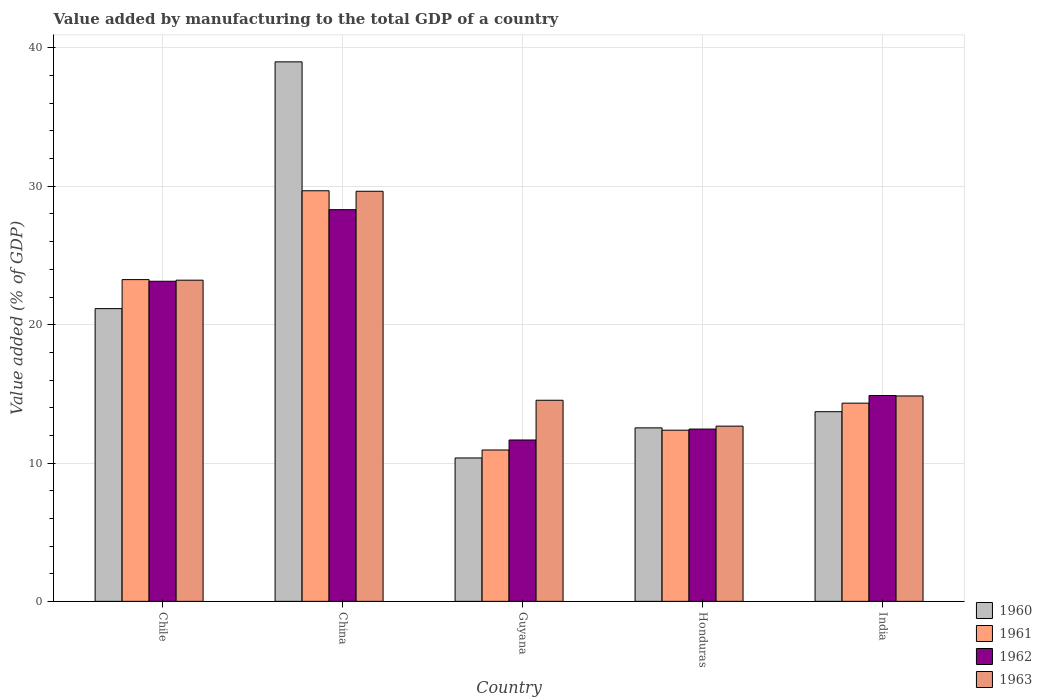How many bars are there on the 5th tick from the left?
Give a very brief answer. 4. How many bars are there on the 4th tick from the right?
Your answer should be compact. 4. What is the label of the 2nd group of bars from the left?
Provide a succinct answer. China. What is the value added by manufacturing to the total GDP in 1961 in China?
Keep it short and to the point. 29.68. Across all countries, what is the maximum value added by manufacturing to the total GDP in 1960?
Provide a succinct answer. 39. Across all countries, what is the minimum value added by manufacturing to the total GDP in 1960?
Keep it short and to the point. 10.37. In which country was the value added by manufacturing to the total GDP in 1963 maximum?
Make the answer very short. China. In which country was the value added by manufacturing to the total GDP in 1962 minimum?
Provide a short and direct response. Guyana. What is the total value added by manufacturing to the total GDP in 1963 in the graph?
Provide a short and direct response. 94.91. What is the difference between the value added by manufacturing to the total GDP in 1961 in China and that in Honduras?
Give a very brief answer. 17.31. What is the difference between the value added by manufacturing to the total GDP in 1961 in India and the value added by manufacturing to the total GDP in 1960 in Guyana?
Provide a succinct answer. 3.96. What is the average value added by manufacturing to the total GDP in 1960 per country?
Ensure brevity in your answer.  19.35. What is the difference between the value added by manufacturing to the total GDP of/in 1963 and value added by manufacturing to the total GDP of/in 1960 in Chile?
Your answer should be very brief. 2.06. What is the ratio of the value added by manufacturing to the total GDP in 1960 in China to that in Honduras?
Provide a succinct answer. 3.11. What is the difference between the highest and the second highest value added by manufacturing to the total GDP in 1962?
Your response must be concise. 13.43. What is the difference between the highest and the lowest value added by manufacturing to the total GDP in 1962?
Your answer should be very brief. 16.65. In how many countries, is the value added by manufacturing to the total GDP in 1963 greater than the average value added by manufacturing to the total GDP in 1963 taken over all countries?
Provide a short and direct response. 2. Is the sum of the value added by manufacturing to the total GDP in 1963 in Chile and Honduras greater than the maximum value added by manufacturing to the total GDP in 1961 across all countries?
Keep it short and to the point. Yes. Is it the case that in every country, the sum of the value added by manufacturing to the total GDP in 1962 and value added by manufacturing to the total GDP in 1963 is greater than the sum of value added by manufacturing to the total GDP in 1960 and value added by manufacturing to the total GDP in 1961?
Make the answer very short. No. What does the 3rd bar from the right in Chile represents?
Offer a very short reply. 1961. Is it the case that in every country, the sum of the value added by manufacturing to the total GDP in 1963 and value added by manufacturing to the total GDP in 1962 is greater than the value added by manufacturing to the total GDP in 1960?
Give a very brief answer. Yes. How many bars are there?
Your response must be concise. 20. How many countries are there in the graph?
Give a very brief answer. 5. What is the difference between two consecutive major ticks on the Y-axis?
Make the answer very short. 10. Are the values on the major ticks of Y-axis written in scientific E-notation?
Make the answer very short. No. How are the legend labels stacked?
Your answer should be compact. Vertical. What is the title of the graph?
Make the answer very short. Value added by manufacturing to the total GDP of a country. Does "1990" appear as one of the legend labels in the graph?
Offer a very short reply. No. What is the label or title of the X-axis?
Your answer should be very brief. Country. What is the label or title of the Y-axis?
Your answer should be very brief. Value added (% of GDP). What is the Value added (% of GDP) of 1960 in Chile?
Your answer should be compact. 21.16. What is the Value added (% of GDP) in 1961 in Chile?
Your answer should be very brief. 23.26. What is the Value added (% of GDP) of 1962 in Chile?
Your answer should be compact. 23.14. What is the Value added (% of GDP) of 1963 in Chile?
Ensure brevity in your answer.  23.22. What is the Value added (% of GDP) in 1960 in China?
Offer a terse response. 39. What is the Value added (% of GDP) in 1961 in China?
Offer a terse response. 29.68. What is the Value added (% of GDP) of 1962 in China?
Your answer should be compact. 28.31. What is the Value added (% of GDP) of 1963 in China?
Ensure brevity in your answer.  29.64. What is the Value added (% of GDP) of 1960 in Guyana?
Keep it short and to the point. 10.37. What is the Value added (% of GDP) of 1961 in Guyana?
Offer a terse response. 10.94. What is the Value added (% of GDP) of 1962 in Guyana?
Keep it short and to the point. 11.66. What is the Value added (% of GDP) in 1963 in Guyana?
Keep it short and to the point. 14.54. What is the Value added (% of GDP) of 1960 in Honduras?
Make the answer very short. 12.54. What is the Value added (% of GDP) of 1961 in Honduras?
Ensure brevity in your answer.  12.37. What is the Value added (% of GDP) of 1962 in Honduras?
Offer a very short reply. 12.45. What is the Value added (% of GDP) of 1963 in Honduras?
Make the answer very short. 12.67. What is the Value added (% of GDP) in 1960 in India?
Keep it short and to the point. 13.71. What is the Value added (% of GDP) of 1961 in India?
Give a very brief answer. 14.33. What is the Value added (% of GDP) of 1962 in India?
Your answer should be very brief. 14.88. What is the Value added (% of GDP) of 1963 in India?
Your answer should be compact. 14.85. Across all countries, what is the maximum Value added (% of GDP) in 1960?
Your answer should be compact. 39. Across all countries, what is the maximum Value added (% of GDP) of 1961?
Provide a succinct answer. 29.68. Across all countries, what is the maximum Value added (% of GDP) in 1962?
Make the answer very short. 28.31. Across all countries, what is the maximum Value added (% of GDP) in 1963?
Provide a succinct answer. 29.64. Across all countries, what is the minimum Value added (% of GDP) in 1960?
Offer a very short reply. 10.37. Across all countries, what is the minimum Value added (% of GDP) of 1961?
Your response must be concise. 10.94. Across all countries, what is the minimum Value added (% of GDP) of 1962?
Make the answer very short. 11.66. Across all countries, what is the minimum Value added (% of GDP) of 1963?
Your answer should be very brief. 12.67. What is the total Value added (% of GDP) in 1960 in the graph?
Your response must be concise. 96.77. What is the total Value added (% of GDP) in 1961 in the graph?
Your response must be concise. 90.58. What is the total Value added (% of GDP) of 1962 in the graph?
Offer a terse response. 90.45. What is the total Value added (% of GDP) of 1963 in the graph?
Offer a terse response. 94.91. What is the difference between the Value added (% of GDP) of 1960 in Chile and that in China?
Make the answer very short. -17.84. What is the difference between the Value added (% of GDP) of 1961 in Chile and that in China?
Ensure brevity in your answer.  -6.42. What is the difference between the Value added (% of GDP) in 1962 in Chile and that in China?
Ensure brevity in your answer.  -5.17. What is the difference between the Value added (% of GDP) of 1963 in Chile and that in China?
Your answer should be compact. -6.43. What is the difference between the Value added (% of GDP) of 1960 in Chile and that in Guyana?
Keep it short and to the point. 10.79. What is the difference between the Value added (% of GDP) in 1961 in Chile and that in Guyana?
Give a very brief answer. 12.32. What is the difference between the Value added (% of GDP) in 1962 in Chile and that in Guyana?
Your answer should be compact. 11.47. What is the difference between the Value added (% of GDP) in 1963 in Chile and that in Guyana?
Keep it short and to the point. 8.68. What is the difference between the Value added (% of GDP) in 1960 in Chile and that in Honduras?
Ensure brevity in your answer.  8.62. What is the difference between the Value added (% of GDP) of 1961 in Chile and that in Honduras?
Your answer should be compact. 10.88. What is the difference between the Value added (% of GDP) in 1962 in Chile and that in Honduras?
Give a very brief answer. 10.68. What is the difference between the Value added (% of GDP) in 1963 in Chile and that in Honduras?
Your answer should be compact. 10.55. What is the difference between the Value added (% of GDP) of 1960 in Chile and that in India?
Provide a succinct answer. 7.45. What is the difference between the Value added (% of GDP) of 1961 in Chile and that in India?
Ensure brevity in your answer.  8.93. What is the difference between the Value added (% of GDP) in 1962 in Chile and that in India?
Your answer should be compact. 8.26. What is the difference between the Value added (% of GDP) of 1963 in Chile and that in India?
Your response must be concise. 8.37. What is the difference between the Value added (% of GDP) in 1960 in China and that in Guyana?
Your response must be concise. 28.63. What is the difference between the Value added (% of GDP) of 1961 in China and that in Guyana?
Keep it short and to the point. 18.74. What is the difference between the Value added (% of GDP) in 1962 in China and that in Guyana?
Provide a short and direct response. 16.65. What is the difference between the Value added (% of GDP) in 1963 in China and that in Guyana?
Your response must be concise. 15.11. What is the difference between the Value added (% of GDP) in 1960 in China and that in Honduras?
Your answer should be very brief. 26.46. What is the difference between the Value added (% of GDP) in 1961 in China and that in Honduras?
Your response must be concise. 17.31. What is the difference between the Value added (% of GDP) of 1962 in China and that in Honduras?
Ensure brevity in your answer.  15.86. What is the difference between the Value added (% of GDP) of 1963 in China and that in Honduras?
Give a very brief answer. 16.98. What is the difference between the Value added (% of GDP) of 1960 in China and that in India?
Offer a very short reply. 25.29. What is the difference between the Value added (% of GDP) of 1961 in China and that in India?
Your response must be concise. 15.35. What is the difference between the Value added (% of GDP) of 1962 in China and that in India?
Provide a succinct answer. 13.43. What is the difference between the Value added (% of GDP) in 1963 in China and that in India?
Give a very brief answer. 14.8. What is the difference between the Value added (% of GDP) in 1960 in Guyana and that in Honduras?
Give a very brief answer. -2.18. What is the difference between the Value added (% of GDP) in 1961 in Guyana and that in Honduras?
Offer a terse response. -1.43. What is the difference between the Value added (% of GDP) in 1962 in Guyana and that in Honduras?
Give a very brief answer. -0.79. What is the difference between the Value added (% of GDP) in 1963 in Guyana and that in Honduras?
Keep it short and to the point. 1.87. What is the difference between the Value added (% of GDP) of 1960 in Guyana and that in India?
Offer a terse response. -3.34. What is the difference between the Value added (% of GDP) in 1961 in Guyana and that in India?
Provide a succinct answer. -3.39. What is the difference between the Value added (% of GDP) of 1962 in Guyana and that in India?
Ensure brevity in your answer.  -3.21. What is the difference between the Value added (% of GDP) in 1963 in Guyana and that in India?
Ensure brevity in your answer.  -0.31. What is the difference between the Value added (% of GDP) of 1960 in Honduras and that in India?
Your answer should be compact. -1.17. What is the difference between the Value added (% of GDP) of 1961 in Honduras and that in India?
Your answer should be very brief. -1.96. What is the difference between the Value added (% of GDP) of 1962 in Honduras and that in India?
Your answer should be very brief. -2.42. What is the difference between the Value added (% of GDP) of 1963 in Honduras and that in India?
Keep it short and to the point. -2.18. What is the difference between the Value added (% of GDP) in 1960 in Chile and the Value added (% of GDP) in 1961 in China?
Make the answer very short. -8.52. What is the difference between the Value added (% of GDP) of 1960 in Chile and the Value added (% of GDP) of 1962 in China?
Ensure brevity in your answer.  -7.15. What is the difference between the Value added (% of GDP) of 1960 in Chile and the Value added (% of GDP) of 1963 in China?
Your answer should be compact. -8.48. What is the difference between the Value added (% of GDP) in 1961 in Chile and the Value added (% of GDP) in 1962 in China?
Your answer should be very brief. -5.06. What is the difference between the Value added (% of GDP) in 1961 in Chile and the Value added (% of GDP) in 1963 in China?
Your answer should be very brief. -6.39. What is the difference between the Value added (% of GDP) of 1962 in Chile and the Value added (% of GDP) of 1963 in China?
Give a very brief answer. -6.51. What is the difference between the Value added (% of GDP) of 1960 in Chile and the Value added (% of GDP) of 1961 in Guyana?
Keep it short and to the point. 10.22. What is the difference between the Value added (% of GDP) in 1960 in Chile and the Value added (% of GDP) in 1962 in Guyana?
Make the answer very short. 9.5. What is the difference between the Value added (% of GDP) of 1960 in Chile and the Value added (% of GDP) of 1963 in Guyana?
Your answer should be compact. 6.62. What is the difference between the Value added (% of GDP) of 1961 in Chile and the Value added (% of GDP) of 1962 in Guyana?
Offer a very short reply. 11.59. What is the difference between the Value added (% of GDP) of 1961 in Chile and the Value added (% of GDP) of 1963 in Guyana?
Provide a succinct answer. 8.72. What is the difference between the Value added (% of GDP) of 1962 in Chile and the Value added (% of GDP) of 1963 in Guyana?
Your answer should be very brief. 8.6. What is the difference between the Value added (% of GDP) in 1960 in Chile and the Value added (% of GDP) in 1961 in Honduras?
Your answer should be compact. 8.79. What is the difference between the Value added (% of GDP) of 1960 in Chile and the Value added (% of GDP) of 1962 in Honduras?
Your answer should be very brief. 8.71. What is the difference between the Value added (% of GDP) of 1960 in Chile and the Value added (% of GDP) of 1963 in Honduras?
Your answer should be very brief. 8.49. What is the difference between the Value added (% of GDP) of 1961 in Chile and the Value added (% of GDP) of 1962 in Honduras?
Provide a succinct answer. 10.8. What is the difference between the Value added (% of GDP) in 1961 in Chile and the Value added (% of GDP) in 1963 in Honduras?
Offer a terse response. 10.59. What is the difference between the Value added (% of GDP) in 1962 in Chile and the Value added (% of GDP) in 1963 in Honduras?
Give a very brief answer. 10.47. What is the difference between the Value added (% of GDP) in 1960 in Chile and the Value added (% of GDP) in 1961 in India?
Provide a short and direct response. 6.83. What is the difference between the Value added (% of GDP) in 1960 in Chile and the Value added (% of GDP) in 1962 in India?
Give a very brief answer. 6.28. What is the difference between the Value added (% of GDP) in 1960 in Chile and the Value added (% of GDP) in 1963 in India?
Your response must be concise. 6.31. What is the difference between the Value added (% of GDP) in 1961 in Chile and the Value added (% of GDP) in 1962 in India?
Your answer should be very brief. 8.38. What is the difference between the Value added (% of GDP) in 1961 in Chile and the Value added (% of GDP) in 1963 in India?
Your response must be concise. 8.41. What is the difference between the Value added (% of GDP) of 1962 in Chile and the Value added (% of GDP) of 1963 in India?
Your answer should be compact. 8.29. What is the difference between the Value added (% of GDP) of 1960 in China and the Value added (% of GDP) of 1961 in Guyana?
Provide a succinct answer. 28.06. What is the difference between the Value added (% of GDP) of 1960 in China and the Value added (% of GDP) of 1962 in Guyana?
Your answer should be compact. 27.33. What is the difference between the Value added (% of GDP) in 1960 in China and the Value added (% of GDP) in 1963 in Guyana?
Offer a very short reply. 24.46. What is the difference between the Value added (% of GDP) in 1961 in China and the Value added (% of GDP) in 1962 in Guyana?
Your response must be concise. 18.02. What is the difference between the Value added (% of GDP) in 1961 in China and the Value added (% of GDP) in 1963 in Guyana?
Offer a very short reply. 15.14. What is the difference between the Value added (% of GDP) in 1962 in China and the Value added (% of GDP) in 1963 in Guyana?
Provide a succinct answer. 13.78. What is the difference between the Value added (% of GDP) in 1960 in China and the Value added (% of GDP) in 1961 in Honduras?
Provide a succinct answer. 26.63. What is the difference between the Value added (% of GDP) of 1960 in China and the Value added (% of GDP) of 1962 in Honduras?
Offer a very short reply. 26.54. What is the difference between the Value added (% of GDP) of 1960 in China and the Value added (% of GDP) of 1963 in Honduras?
Keep it short and to the point. 26.33. What is the difference between the Value added (% of GDP) in 1961 in China and the Value added (% of GDP) in 1962 in Honduras?
Keep it short and to the point. 17.23. What is the difference between the Value added (% of GDP) in 1961 in China and the Value added (% of GDP) in 1963 in Honduras?
Keep it short and to the point. 17.01. What is the difference between the Value added (% of GDP) in 1962 in China and the Value added (% of GDP) in 1963 in Honduras?
Your answer should be very brief. 15.65. What is the difference between the Value added (% of GDP) of 1960 in China and the Value added (% of GDP) of 1961 in India?
Provide a succinct answer. 24.67. What is the difference between the Value added (% of GDP) of 1960 in China and the Value added (% of GDP) of 1962 in India?
Offer a very short reply. 24.12. What is the difference between the Value added (% of GDP) in 1960 in China and the Value added (% of GDP) in 1963 in India?
Your answer should be very brief. 24.15. What is the difference between the Value added (% of GDP) of 1961 in China and the Value added (% of GDP) of 1962 in India?
Make the answer very short. 14.8. What is the difference between the Value added (% of GDP) of 1961 in China and the Value added (% of GDP) of 1963 in India?
Provide a succinct answer. 14.83. What is the difference between the Value added (% of GDP) in 1962 in China and the Value added (% of GDP) in 1963 in India?
Ensure brevity in your answer.  13.47. What is the difference between the Value added (% of GDP) of 1960 in Guyana and the Value added (% of GDP) of 1961 in Honduras?
Your response must be concise. -2.01. What is the difference between the Value added (% of GDP) of 1960 in Guyana and the Value added (% of GDP) of 1962 in Honduras?
Your response must be concise. -2.09. What is the difference between the Value added (% of GDP) in 1960 in Guyana and the Value added (% of GDP) in 1963 in Honduras?
Your answer should be compact. -2.3. What is the difference between the Value added (% of GDP) of 1961 in Guyana and the Value added (% of GDP) of 1962 in Honduras?
Ensure brevity in your answer.  -1.51. What is the difference between the Value added (% of GDP) of 1961 in Guyana and the Value added (% of GDP) of 1963 in Honduras?
Give a very brief answer. -1.73. What is the difference between the Value added (% of GDP) in 1962 in Guyana and the Value added (% of GDP) in 1963 in Honduras?
Offer a very short reply. -1. What is the difference between the Value added (% of GDP) in 1960 in Guyana and the Value added (% of GDP) in 1961 in India?
Your answer should be very brief. -3.96. What is the difference between the Value added (% of GDP) in 1960 in Guyana and the Value added (% of GDP) in 1962 in India?
Ensure brevity in your answer.  -4.51. What is the difference between the Value added (% of GDP) of 1960 in Guyana and the Value added (% of GDP) of 1963 in India?
Ensure brevity in your answer.  -4.48. What is the difference between the Value added (% of GDP) in 1961 in Guyana and the Value added (% of GDP) in 1962 in India?
Your response must be concise. -3.94. What is the difference between the Value added (% of GDP) of 1961 in Guyana and the Value added (% of GDP) of 1963 in India?
Provide a succinct answer. -3.91. What is the difference between the Value added (% of GDP) in 1962 in Guyana and the Value added (% of GDP) in 1963 in India?
Your response must be concise. -3.18. What is the difference between the Value added (% of GDP) of 1960 in Honduras and the Value added (% of GDP) of 1961 in India?
Provide a succinct answer. -1.79. What is the difference between the Value added (% of GDP) in 1960 in Honduras and the Value added (% of GDP) in 1962 in India?
Offer a very short reply. -2.34. What is the difference between the Value added (% of GDP) of 1960 in Honduras and the Value added (% of GDP) of 1963 in India?
Keep it short and to the point. -2.31. What is the difference between the Value added (% of GDP) in 1961 in Honduras and the Value added (% of GDP) in 1962 in India?
Give a very brief answer. -2.51. What is the difference between the Value added (% of GDP) of 1961 in Honduras and the Value added (% of GDP) of 1963 in India?
Make the answer very short. -2.47. What is the difference between the Value added (% of GDP) of 1962 in Honduras and the Value added (% of GDP) of 1963 in India?
Your answer should be very brief. -2.39. What is the average Value added (% of GDP) in 1960 per country?
Give a very brief answer. 19.36. What is the average Value added (% of GDP) of 1961 per country?
Your answer should be very brief. 18.12. What is the average Value added (% of GDP) in 1962 per country?
Your answer should be compact. 18.09. What is the average Value added (% of GDP) in 1963 per country?
Give a very brief answer. 18.98. What is the difference between the Value added (% of GDP) in 1960 and Value added (% of GDP) in 1961 in Chile?
Your answer should be very brief. -2.1. What is the difference between the Value added (% of GDP) of 1960 and Value added (% of GDP) of 1962 in Chile?
Make the answer very short. -1.98. What is the difference between the Value added (% of GDP) in 1960 and Value added (% of GDP) in 1963 in Chile?
Offer a very short reply. -2.06. What is the difference between the Value added (% of GDP) in 1961 and Value added (% of GDP) in 1962 in Chile?
Provide a short and direct response. 0.12. What is the difference between the Value added (% of GDP) of 1961 and Value added (% of GDP) of 1963 in Chile?
Your response must be concise. 0.04. What is the difference between the Value added (% of GDP) in 1962 and Value added (% of GDP) in 1963 in Chile?
Your answer should be compact. -0.08. What is the difference between the Value added (% of GDP) in 1960 and Value added (% of GDP) in 1961 in China?
Make the answer very short. 9.32. What is the difference between the Value added (% of GDP) of 1960 and Value added (% of GDP) of 1962 in China?
Provide a short and direct response. 10.69. What is the difference between the Value added (% of GDP) of 1960 and Value added (% of GDP) of 1963 in China?
Your answer should be compact. 9.35. What is the difference between the Value added (% of GDP) in 1961 and Value added (% of GDP) in 1962 in China?
Offer a terse response. 1.37. What is the difference between the Value added (% of GDP) in 1961 and Value added (% of GDP) in 1963 in China?
Provide a succinct answer. 0.04. What is the difference between the Value added (% of GDP) of 1962 and Value added (% of GDP) of 1963 in China?
Your answer should be compact. -1.33. What is the difference between the Value added (% of GDP) of 1960 and Value added (% of GDP) of 1961 in Guyana?
Offer a very short reply. -0.58. What is the difference between the Value added (% of GDP) of 1960 and Value added (% of GDP) of 1962 in Guyana?
Offer a very short reply. -1.3. What is the difference between the Value added (% of GDP) in 1960 and Value added (% of GDP) in 1963 in Guyana?
Ensure brevity in your answer.  -4.17. What is the difference between the Value added (% of GDP) in 1961 and Value added (% of GDP) in 1962 in Guyana?
Make the answer very short. -0.72. What is the difference between the Value added (% of GDP) of 1961 and Value added (% of GDP) of 1963 in Guyana?
Offer a very short reply. -3.6. What is the difference between the Value added (% of GDP) of 1962 and Value added (% of GDP) of 1963 in Guyana?
Provide a succinct answer. -2.87. What is the difference between the Value added (% of GDP) of 1960 and Value added (% of GDP) of 1961 in Honduras?
Give a very brief answer. 0.17. What is the difference between the Value added (% of GDP) of 1960 and Value added (% of GDP) of 1962 in Honduras?
Offer a terse response. 0.09. What is the difference between the Value added (% of GDP) in 1960 and Value added (% of GDP) in 1963 in Honduras?
Your answer should be very brief. -0.13. What is the difference between the Value added (% of GDP) in 1961 and Value added (% of GDP) in 1962 in Honduras?
Give a very brief answer. -0.08. What is the difference between the Value added (% of GDP) of 1961 and Value added (% of GDP) of 1963 in Honduras?
Make the answer very short. -0.29. What is the difference between the Value added (% of GDP) in 1962 and Value added (% of GDP) in 1963 in Honduras?
Your response must be concise. -0.21. What is the difference between the Value added (% of GDP) in 1960 and Value added (% of GDP) in 1961 in India?
Keep it short and to the point. -0.62. What is the difference between the Value added (% of GDP) in 1960 and Value added (% of GDP) in 1962 in India?
Offer a very short reply. -1.17. What is the difference between the Value added (% of GDP) of 1960 and Value added (% of GDP) of 1963 in India?
Make the answer very short. -1.14. What is the difference between the Value added (% of GDP) in 1961 and Value added (% of GDP) in 1962 in India?
Offer a terse response. -0.55. What is the difference between the Value added (% of GDP) in 1961 and Value added (% of GDP) in 1963 in India?
Offer a very short reply. -0.52. What is the difference between the Value added (% of GDP) of 1962 and Value added (% of GDP) of 1963 in India?
Your answer should be very brief. 0.03. What is the ratio of the Value added (% of GDP) of 1960 in Chile to that in China?
Make the answer very short. 0.54. What is the ratio of the Value added (% of GDP) of 1961 in Chile to that in China?
Provide a succinct answer. 0.78. What is the ratio of the Value added (% of GDP) of 1962 in Chile to that in China?
Your response must be concise. 0.82. What is the ratio of the Value added (% of GDP) of 1963 in Chile to that in China?
Provide a succinct answer. 0.78. What is the ratio of the Value added (% of GDP) in 1960 in Chile to that in Guyana?
Provide a succinct answer. 2.04. What is the ratio of the Value added (% of GDP) in 1961 in Chile to that in Guyana?
Make the answer very short. 2.13. What is the ratio of the Value added (% of GDP) in 1962 in Chile to that in Guyana?
Keep it short and to the point. 1.98. What is the ratio of the Value added (% of GDP) in 1963 in Chile to that in Guyana?
Offer a terse response. 1.6. What is the ratio of the Value added (% of GDP) in 1960 in Chile to that in Honduras?
Keep it short and to the point. 1.69. What is the ratio of the Value added (% of GDP) of 1961 in Chile to that in Honduras?
Offer a very short reply. 1.88. What is the ratio of the Value added (% of GDP) in 1962 in Chile to that in Honduras?
Your response must be concise. 1.86. What is the ratio of the Value added (% of GDP) of 1963 in Chile to that in Honduras?
Your response must be concise. 1.83. What is the ratio of the Value added (% of GDP) in 1960 in Chile to that in India?
Ensure brevity in your answer.  1.54. What is the ratio of the Value added (% of GDP) in 1961 in Chile to that in India?
Provide a short and direct response. 1.62. What is the ratio of the Value added (% of GDP) in 1962 in Chile to that in India?
Make the answer very short. 1.56. What is the ratio of the Value added (% of GDP) in 1963 in Chile to that in India?
Offer a very short reply. 1.56. What is the ratio of the Value added (% of GDP) in 1960 in China to that in Guyana?
Ensure brevity in your answer.  3.76. What is the ratio of the Value added (% of GDP) in 1961 in China to that in Guyana?
Give a very brief answer. 2.71. What is the ratio of the Value added (% of GDP) in 1962 in China to that in Guyana?
Your answer should be compact. 2.43. What is the ratio of the Value added (% of GDP) in 1963 in China to that in Guyana?
Make the answer very short. 2.04. What is the ratio of the Value added (% of GDP) in 1960 in China to that in Honduras?
Your answer should be very brief. 3.11. What is the ratio of the Value added (% of GDP) of 1961 in China to that in Honduras?
Offer a very short reply. 2.4. What is the ratio of the Value added (% of GDP) of 1962 in China to that in Honduras?
Your response must be concise. 2.27. What is the ratio of the Value added (% of GDP) of 1963 in China to that in Honduras?
Your answer should be compact. 2.34. What is the ratio of the Value added (% of GDP) of 1960 in China to that in India?
Your answer should be very brief. 2.84. What is the ratio of the Value added (% of GDP) in 1961 in China to that in India?
Your answer should be compact. 2.07. What is the ratio of the Value added (% of GDP) in 1962 in China to that in India?
Keep it short and to the point. 1.9. What is the ratio of the Value added (% of GDP) of 1963 in China to that in India?
Offer a very short reply. 2. What is the ratio of the Value added (% of GDP) in 1960 in Guyana to that in Honduras?
Provide a short and direct response. 0.83. What is the ratio of the Value added (% of GDP) in 1961 in Guyana to that in Honduras?
Provide a succinct answer. 0.88. What is the ratio of the Value added (% of GDP) of 1962 in Guyana to that in Honduras?
Offer a terse response. 0.94. What is the ratio of the Value added (% of GDP) of 1963 in Guyana to that in Honduras?
Keep it short and to the point. 1.15. What is the ratio of the Value added (% of GDP) in 1960 in Guyana to that in India?
Provide a succinct answer. 0.76. What is the ratio of the Value added (% of GDP) of 1961 in Guyana to that in India?
Ensure brevity in your answer.  0.76. What is the ratio of the Value added (% of GDP) in 1962 in Guyana to that in India?
Your answer should be very brief. 0.78. What is the ratio of the Value added (% of GDP) in 1963 in Guyana to that in India?
Your response must be concise. 0.98. What is the ratio of the Value added (% of GDP) of 1960 in Honduras to that in India?
Make the answer very short. 0.91. What is the ratio of the Value added (% of GDP) in 1961 in Honduras to that in India?
Your response must be concise. 0.86. What is the ratio of the Value added (% of GDP) in 1962 in Honduras to that in India?
Give a very brief answer. 0.84. What is the ratio of the Value added (% of GDP) of 1963 in Honduras to that in India?
Offer a terse response. 0.85. What is the difference between the highest and the second highest Value added (% of GDP) in 1960?
Provide a short and direct response. 17.84. What is the difference between the highest and the second highest Value added (% of GDP) in 1961?
Offer a very short reply. 6.42. What is the difference between the highest and the second highest Value added (% of GDP) in 1962?
Your answer should be very brief. 5.17. What is the difference between the highest and the second highest Value added (% of GDP) of 1963?
Ensure brevity in your answer.  6.43. What is the difference between the highest and the lowest Value added (% of GDP) of 1960?
Offer a terse response. 28.63. What is the difference between the highest and the lowest Value added (% of GDP) of 1961?
Your answer should be very brief. 18.74. What is the difference between the highest and the lowest Value added (% of GDP) in 1962?
Your answer should be compact. 16.65. What is the difference between the highest and the lowest Value added (% of GDP) of 1963?
Offer a terse response. 16.98. 